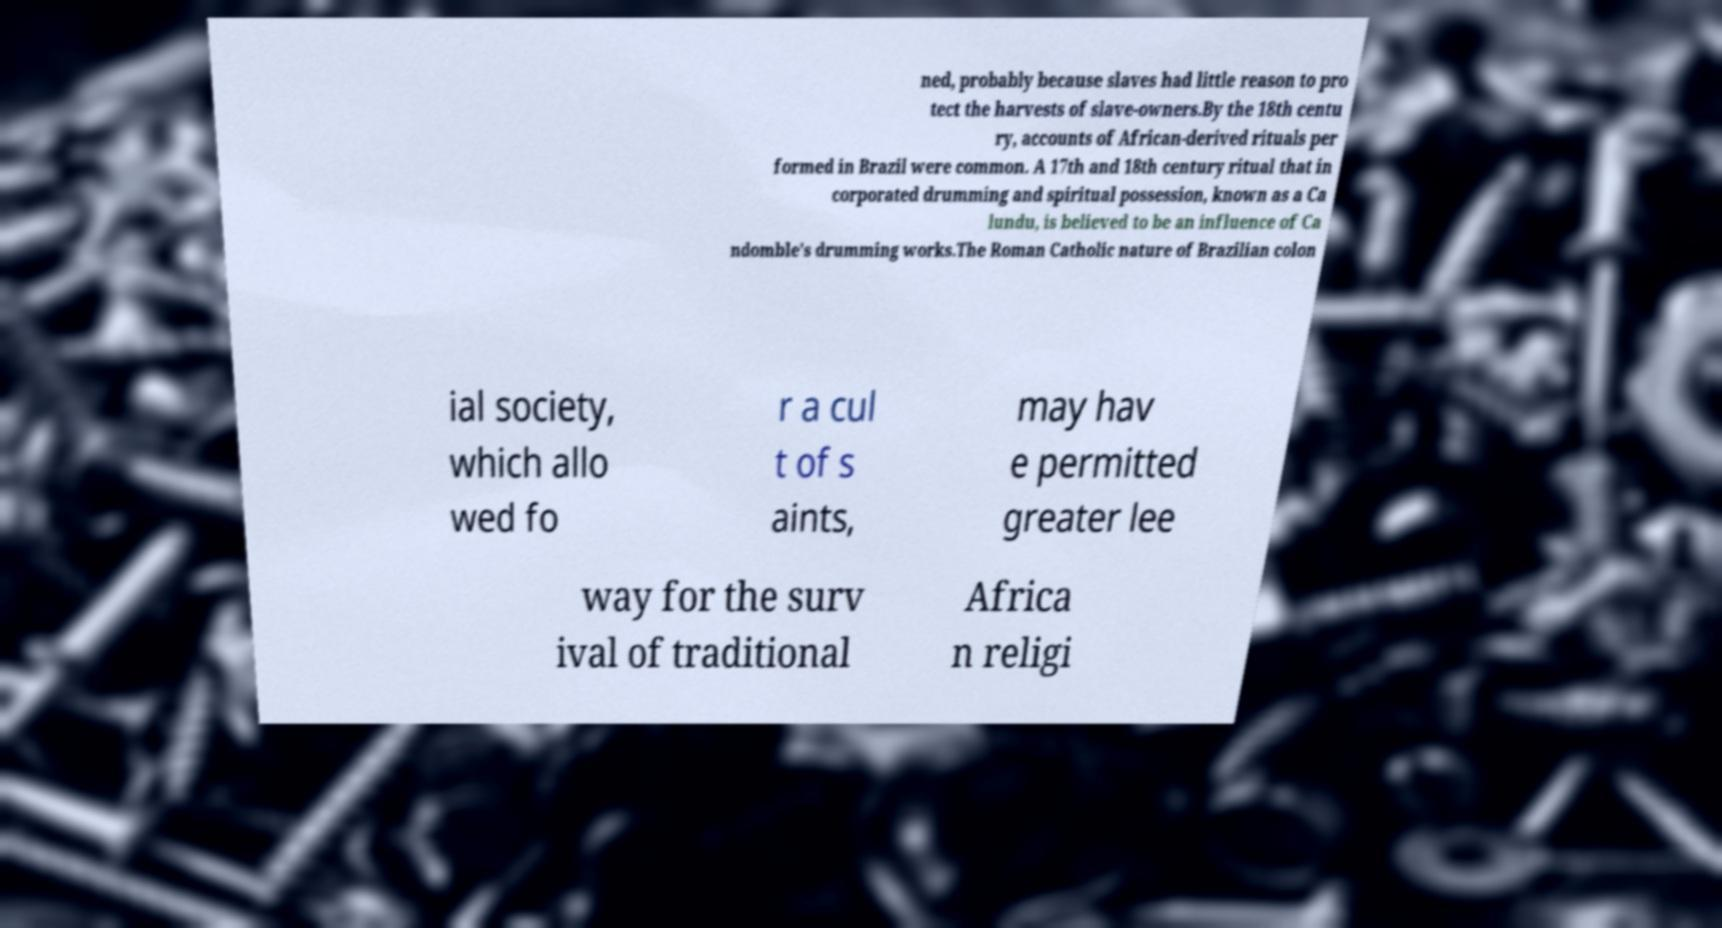Could you assist in decoding the text presented in this image and type it out clearly? ned, probably because slaves had little reason to pro tect the harvests of slave-owners.By the 18th centu ry, accounts of African-derived rituals per formed in Brazil were common. A 17th and 18th century ritual that in corporated drumming and spiritual possession, known as a Ca lundu, is believed to be an influence of Ca ndomble's drumming works.The Roman Catholic nature of Brazilian colon ial society, which allo wed fo r a cul t of s aints, may hav e permitted greater lee way for the surv ival of traditional Africa n religi 